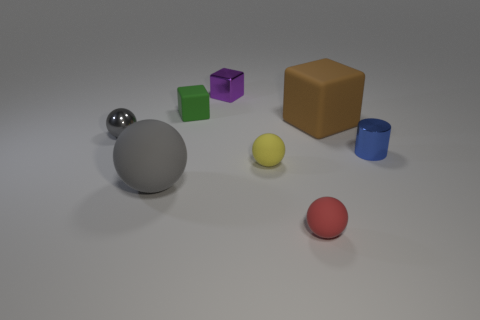If I were to sort the objects by size, starting with the smallest, which order should they go in? Starting with the smallest, the order should be the small yellow ball, the red rubber ball, the blue cylinder, the purple cube, the silver sphere, the green cube, and finally, the largest object would be the orange cube. 